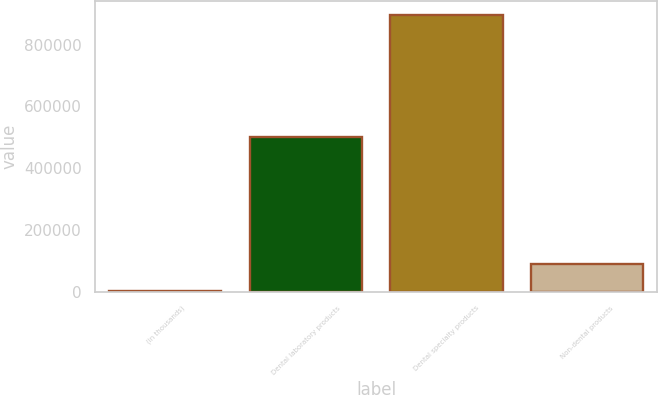Convert chart to OTSL. <chart><loc_0><loc_0><loc_500><loc_500><bar_chart><fcel>(in thousands)<fcel>Dental laboratory products<fcel>Dental specialty products<fcel>Non-dental products<nl><fcel>2009<fcel>500235<fcel>895357<fcel>91343.8<nl></chart> 